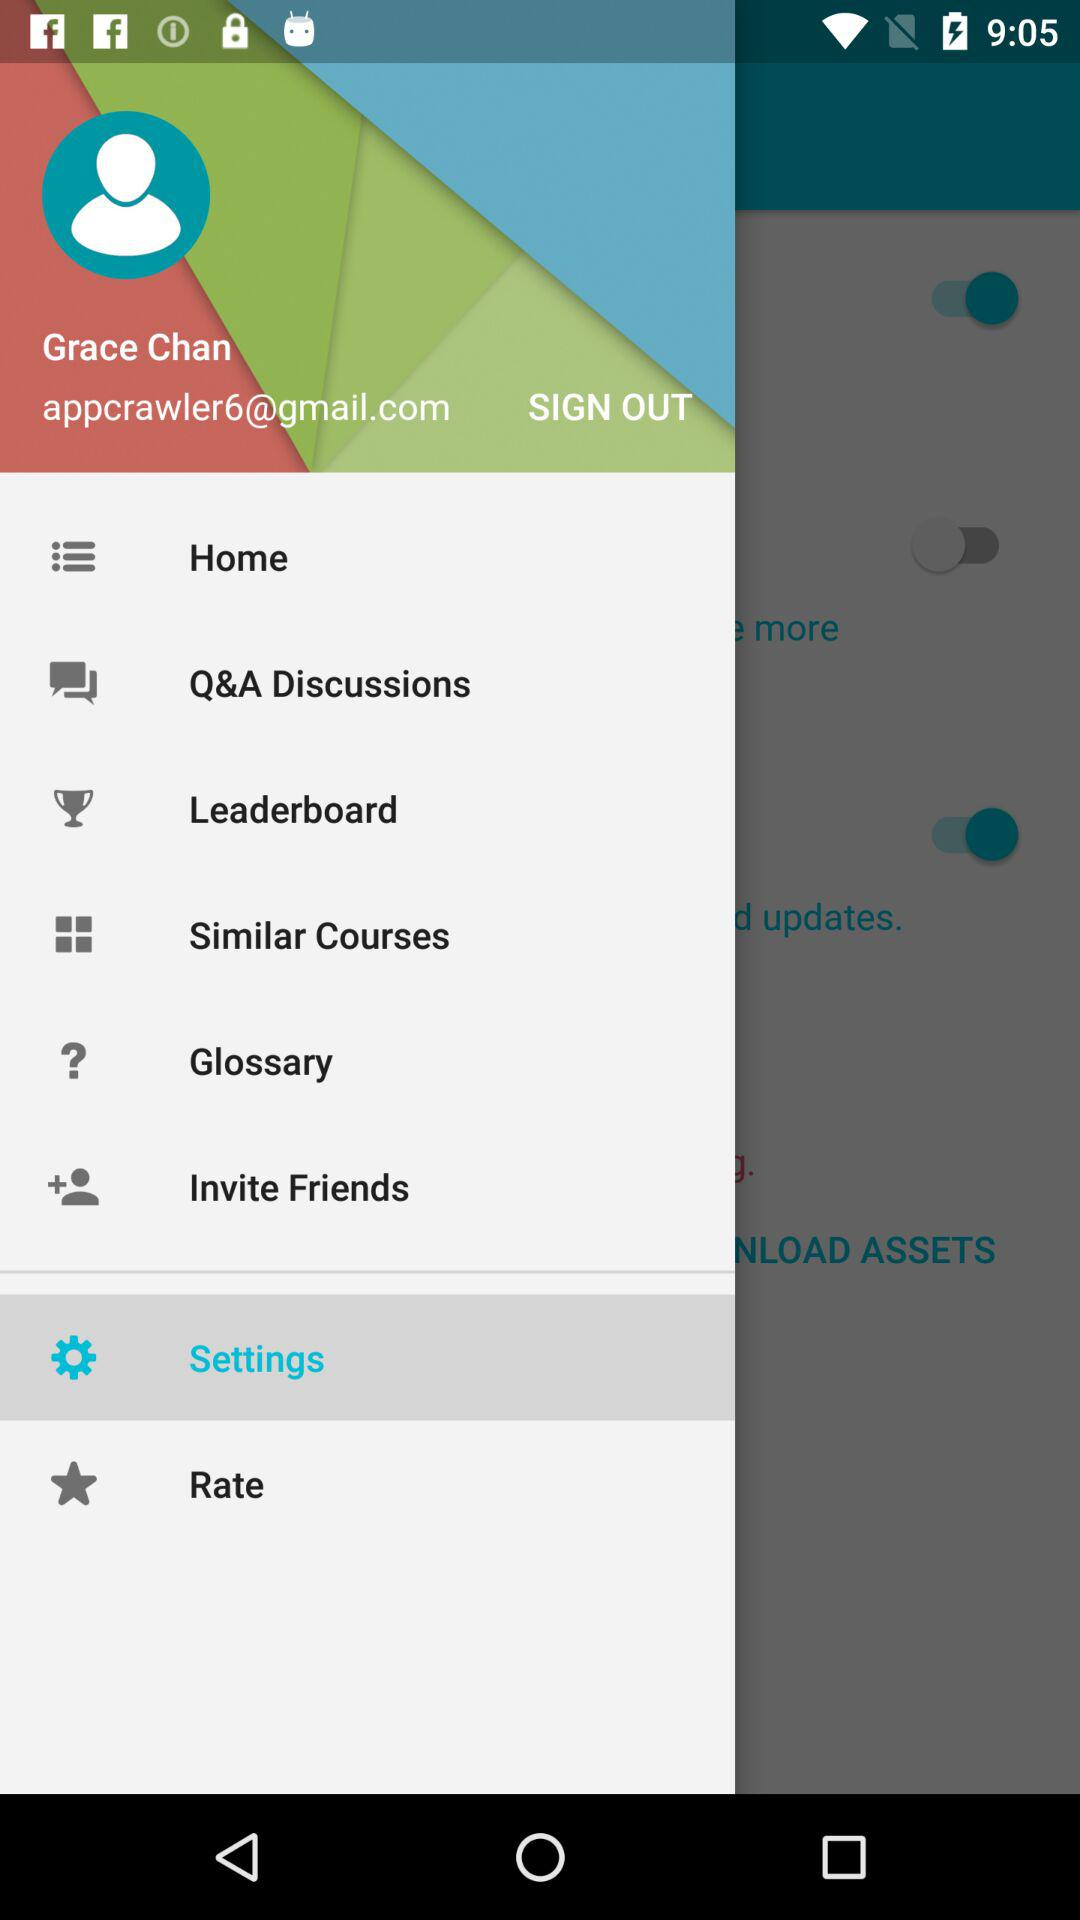Which option is selected? The selected option is Settings. 